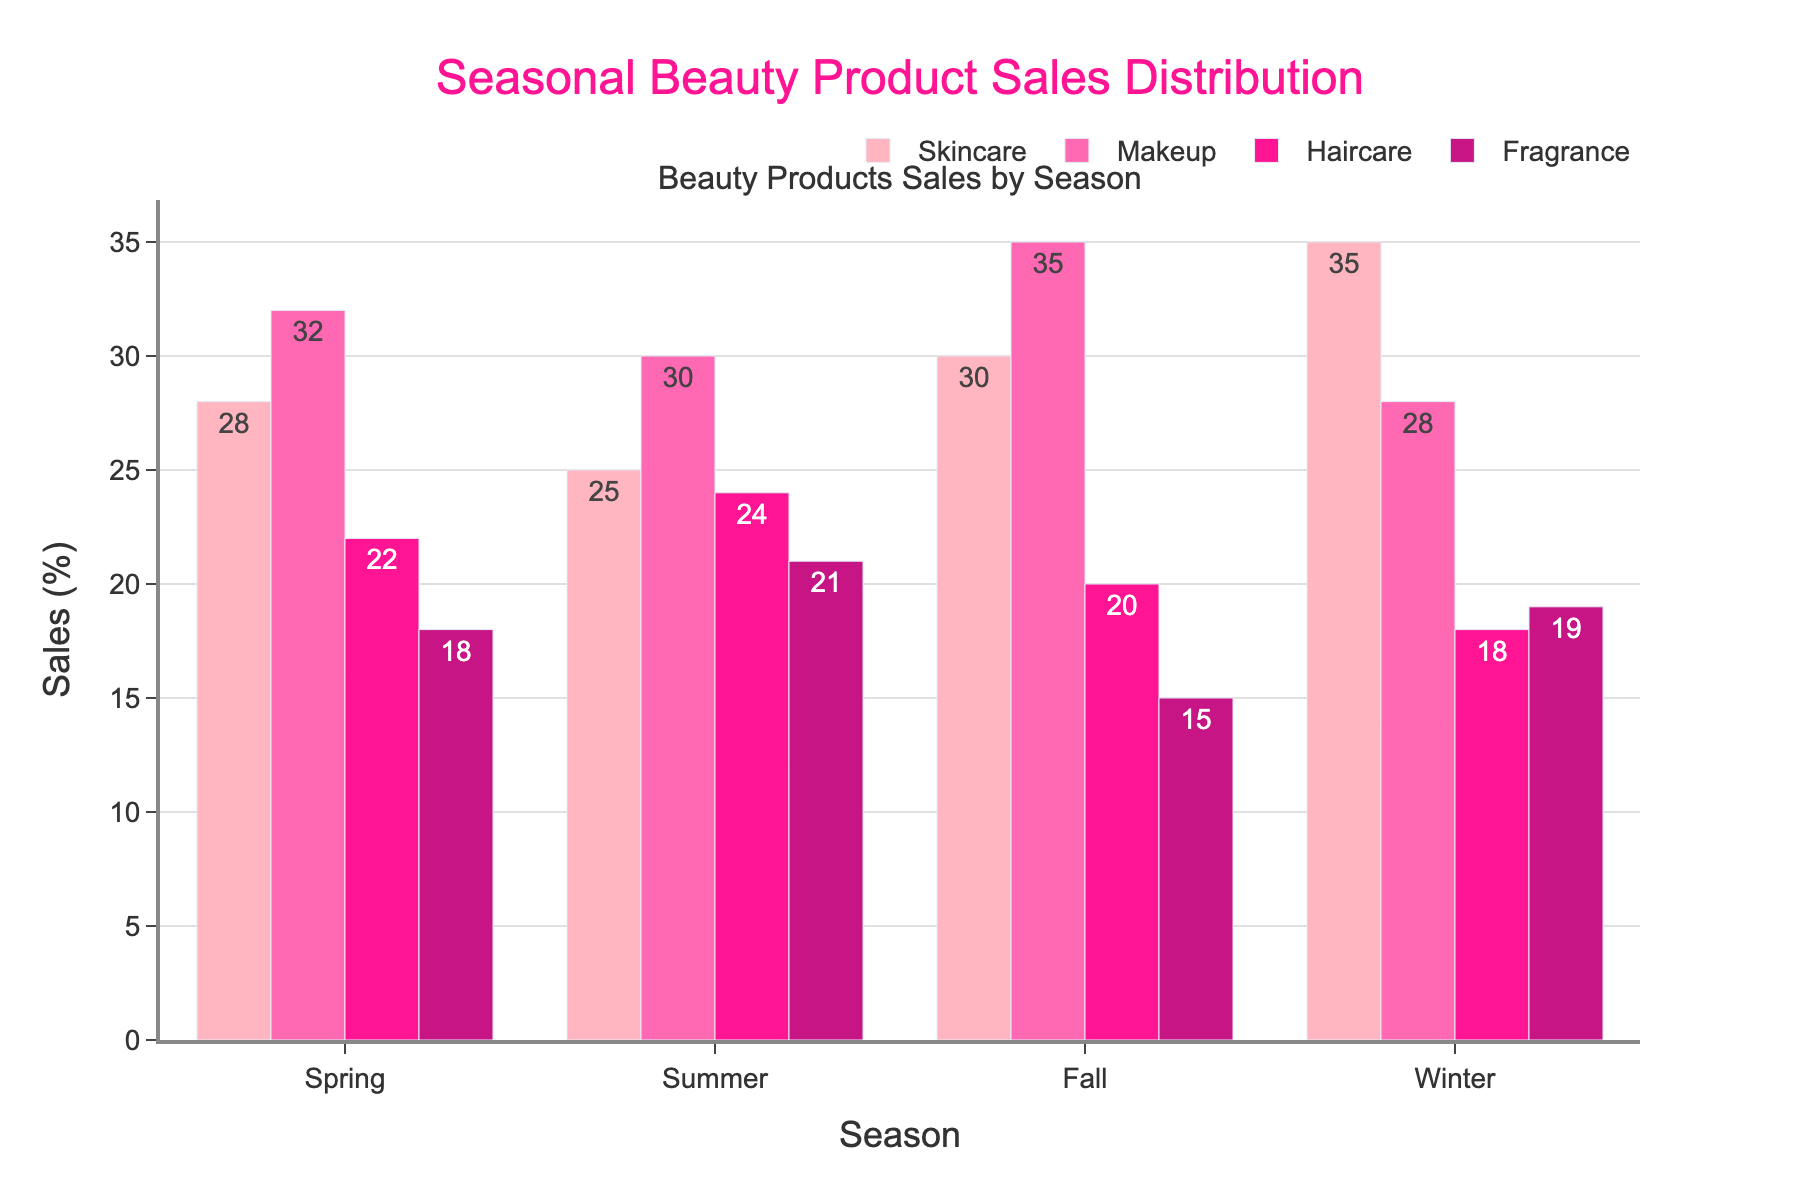Which season has the highest Skincare sales? By looking at the height of the bars representing Skincare sales across different seasons, the bar for Winter is the tallest. Therefore, Winter has the highest Skincare sales.
Answer: Winter Which season has the lowest sales for Fragrance? By comparing the height of the bars for Fragrance in each season, the Fall season has the shortest bar, indicating the lowest sales.
Answer: Fall What's the difference in Makeup sales between Fall and Spring? The bar for Makeup in Fall is at 35, and in Spring, it is at 32. Subtracting these values gives 35 - 32 = 3.
Answer: 3 In which season are the Haircare and Fragrance sales almost equal? By visually comparing the heights of the Haircare and Fragrance bars across the seasons, they appear almost equal in Summer with Haircare at 24 and Fragrance at 21.
Answer: Summer Which category has the most significant sales drop from Spring to Winter? For each category, subtract Winter sales from Spring sales: Skincare (35-28=7), Makeup (28-32=-4), Haircare (18-22=-4), and Fragrance (19-18=1). Haircare and Makeup have the highest drops (4). Comparing these values, Haircare and Makeup experiences the most significant loss.
Answer: Skincare How many seasons have Skincare sales higher than 30? Counting the bars in the Skincare category with heights above 30, we find Fall (30) and Winter (35) fulfilling this criterion. That's two seasons.
Answer: 2 Which two seasons have the closest totals across all categories? Adding up the sales for each season: Spring (28+32+22+18=100), Summer (25+30+24+21=100), Fall (30+35+20+15=100), and Winter (35+28+18+19=100). All seasons have the same total, so they are all equally close.
Answer: All seasons In which season is the difference between Skincare and Makeup sales the greatest? Calculate the absolute difference in sales for Skincare and Makeup for each season: 
Spring (32-28=4), Summer (30-25=5), Fall (35-30=5), Winter (35-28=7). Winter has the greatest difference at 7.
Answer: Winter 